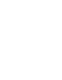Convert code to text. <code><loc_0><loc_0><loc_500><loc_500><_Nim_>















</code> 